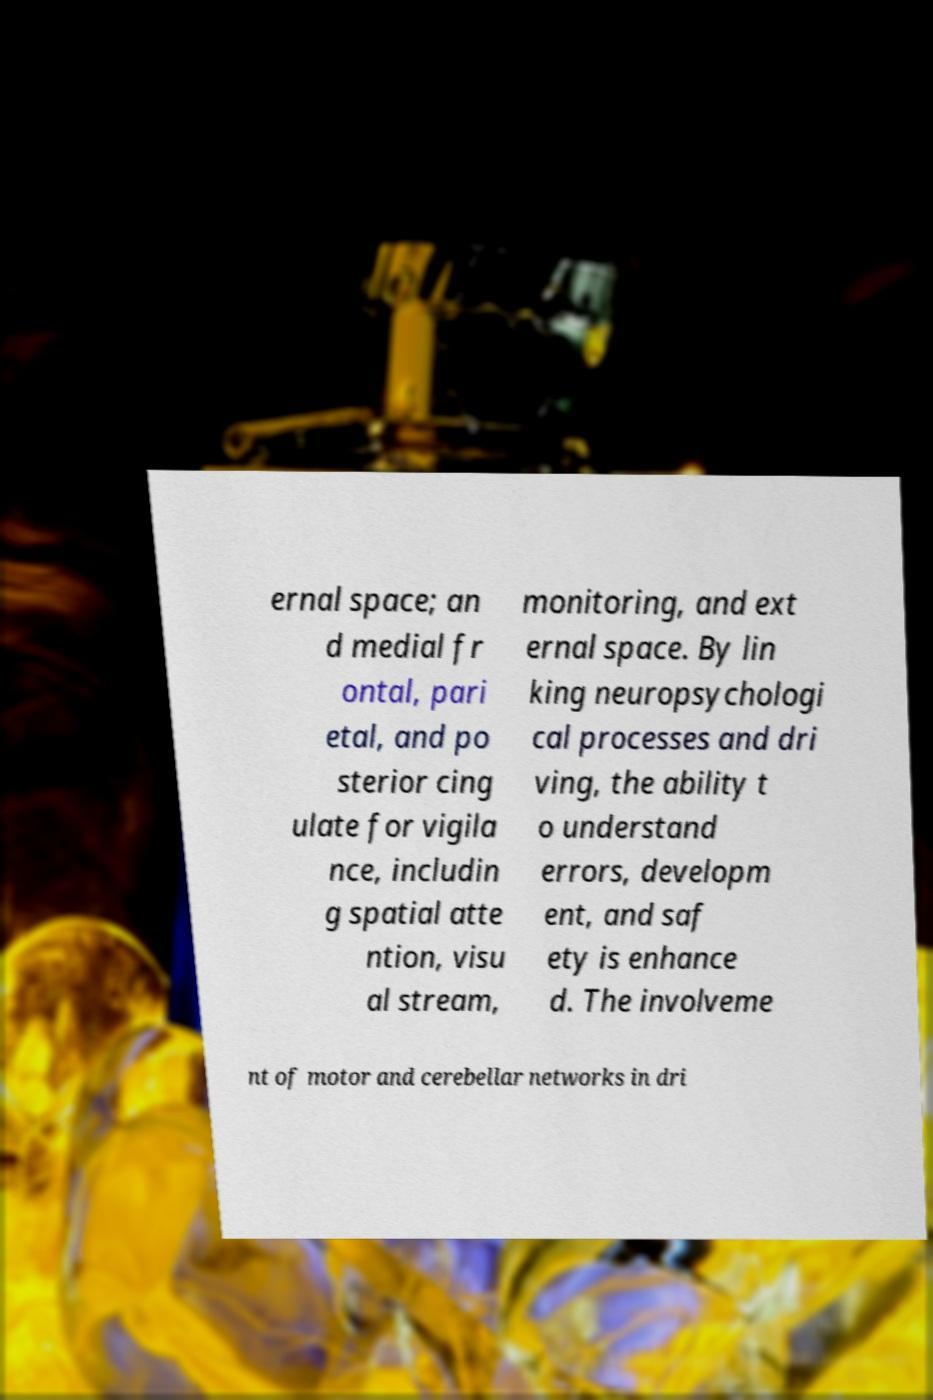For documentation purposes, I need the text within this image transcribed. Could you provide that? ernal space; an d medial fr ontal, pari etal, and po sterior cing ulate for vigila nce, includin g spatial atte ntion, visu al stream, monitoring, and ext ernal space. By lin king neuropsychologi cal processes and dri ving, the ability t o understand errors, developm ent, and saf ety is enhance d. The involveme nt of motor and cerebellar networks in dri 